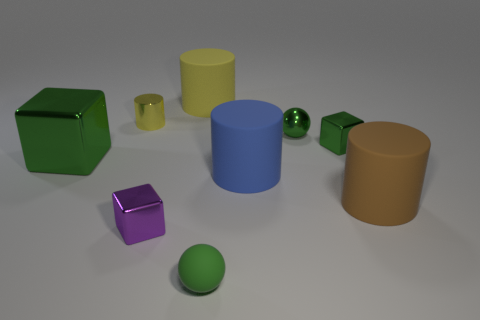There is a purple object that is made of the same material as the tiny green cube; what shape is it? cube 